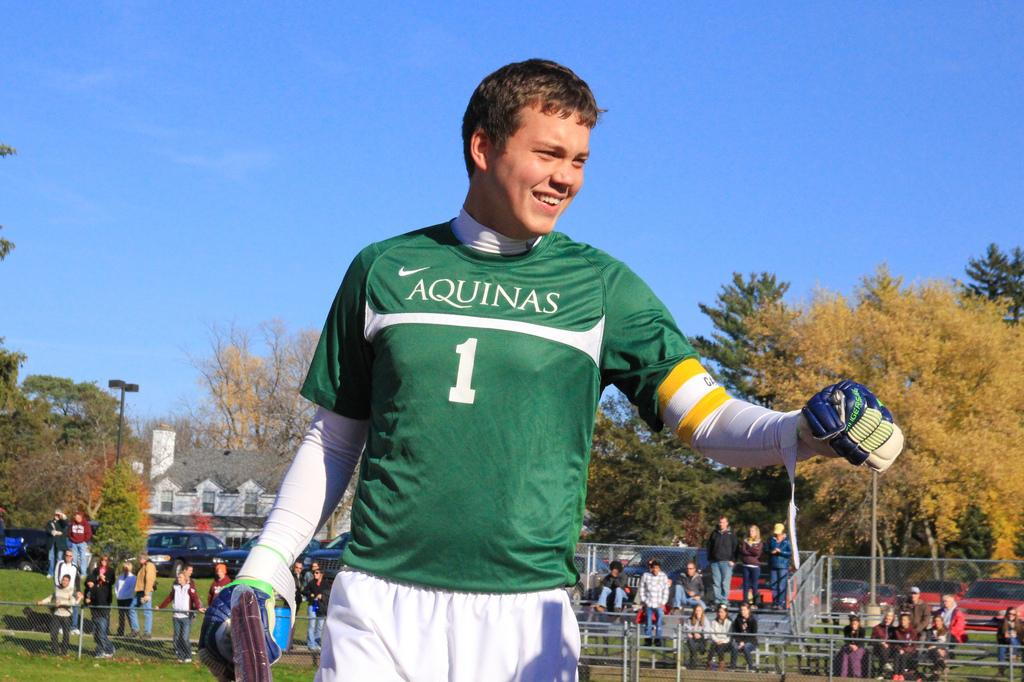<image>
Share a concise interpretation of the image provided. The green shirt the player is wearing is sponsored by Aquinas 